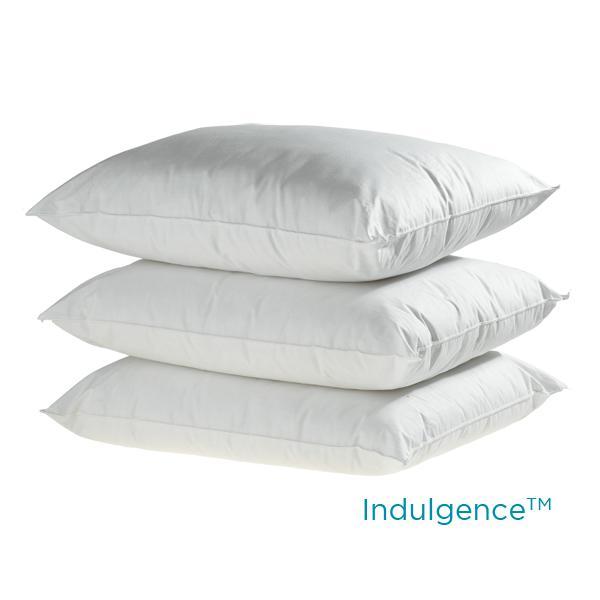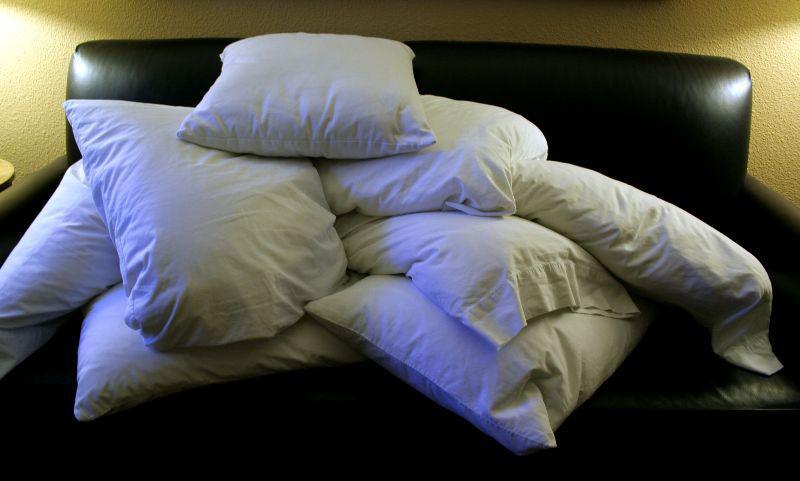The first image is the image on the left, the second image is the image on the right. Given the left and right images, does the statement "An image includes a pile of at least 10 white pillows." hold true? Answer yes or no. No. The first image is the image on the left, the second image is the image on the right. Assess this claim about the two images: "There is a single uncovered pillow in the left image.". Correct or not? Answer yes or no. No. 